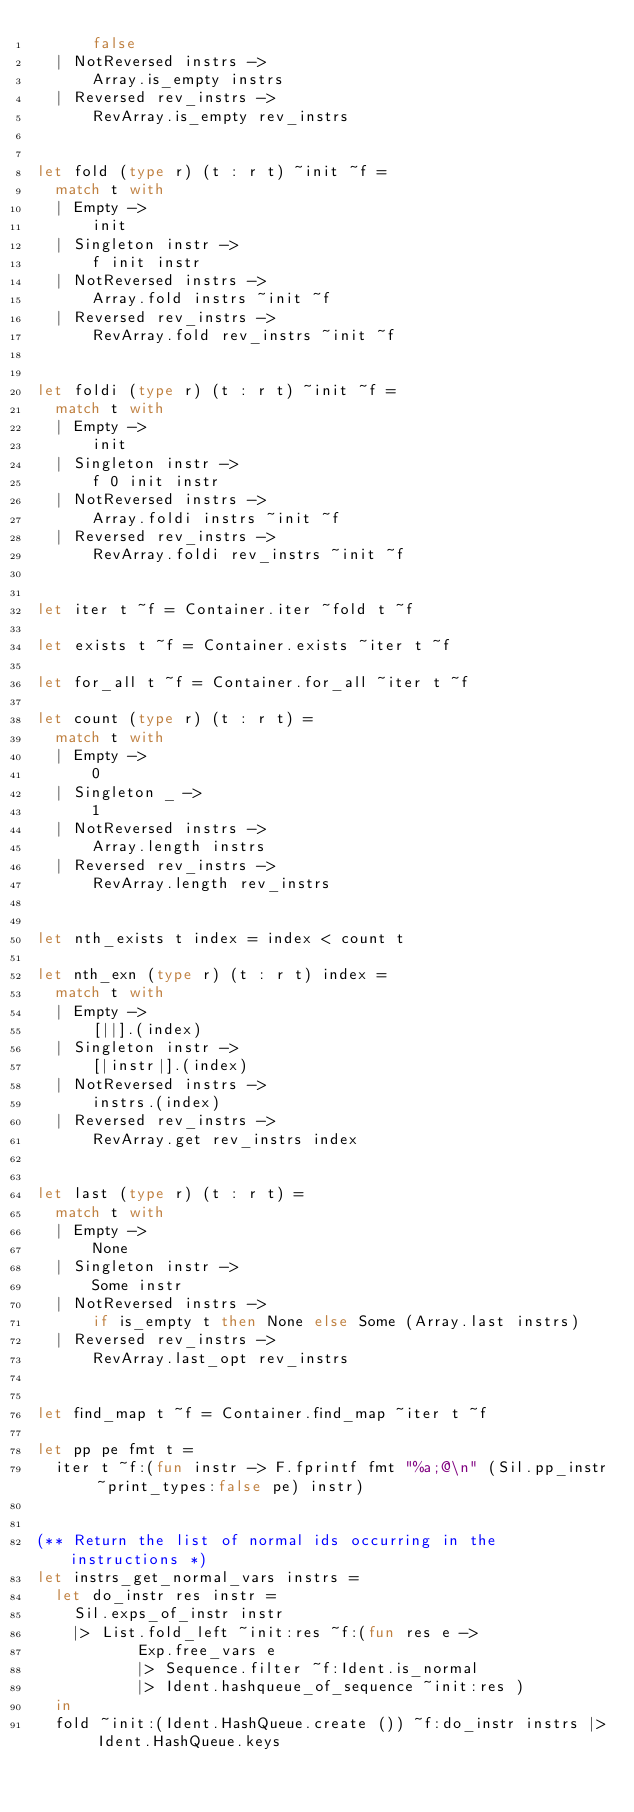Convert code to text. <code><loc_0><loc_0><loc_500><loc_500><_OCaml_>      false
  | NotReversed instrs ->
      Array.is_empty instrs
  | Reversed rev_instrs ->
      RevArray.is_empty rev_instrs


let fold (type r) (t : r t) ~init ~f =
  match t with
  | Empty ->
      init
  | Singleton instr ->
      f init instr
  | NotReversed instrs ->
      Array.fold instrs ~init ~f
  | Reversed rev_instrs ->
      RevArray.fold rev_instrs ~init ~f


let foldi (type r) (t : r t) ~init ~f =
  match t with
  | Empty ->
      init
  | Singleton instr ->
      f 0 init instr
  | NotReversed instrs ->
      Array.foldi instrs ~init ~f
  | Reversed rev_instrs ->
      RevArray.foldi rev_instrs ~init ~f


let iter t ~f = Container.iter ~fold t ~f

let exists t ~f = Container.exists ~iter t ~f

let for_all t ~f = Container.for_all ~iter t ~f

let count (type r) (t : r t) =
  match t with
  | Empty ->
      0
  | Singleton _ ->
      1
  | NotReversed instrs ->
      Array.length instrs
  | Reversed rev_instrs ->
      RevArray.length rev_instrs


let nth_exists t index = index < count t

let nth_exn (type r) (t : r t) index =
  match t with
  | Empty ->
      [||].(index)
  | Singleton instr ->
      [|instr|].(index)
  | NotReversed instrs ->
      instrs.(index)
  | Reversed rev_instrs ->
      RevArray.get rev_instrs index


let last (type r) (t : r t) =
  match t with
  | Empty ->
      None
  | Singleton instr ->
      Some instr
  | NotReversed instrs ->
      if is_empty t then None else Some (Array.last instrs)
  | Reversed rev_instrs ->
      RevArray.last_opt rev_instrs


let find_map t ~f = Container.find_map ~iter t ~f

let pp pe fmt t =
  iter t ~f:(fun instr -> F.fprintf fmt "%a;@\n" (Sil.pp_instr ~print_types:false pe) instr)


(** Return the list of normal ids occurring in the instructions *)
let instrs_get_normal_vars instrs =
  let do_instr res instr =
    Sil.exps_of_instr instr
    |> List.fold_left ~init:res ~f:(fun res e ->
           Exp.free_vars e
           |> Sequence.filter ~f:Ident.is_normal
           |> Ident.hashqueue_of_sequence ~init:res )
  in
  fold ~init:(Ident.HashQueue.create ()) ~f:do_instr instrs |> Ident.HashQueue.keys
</code> 